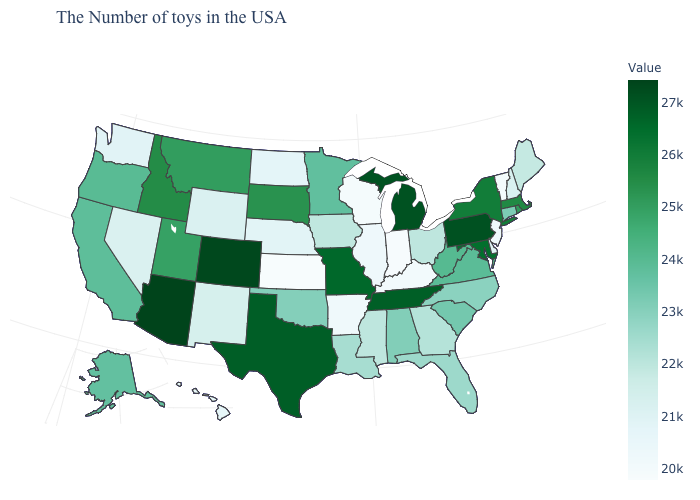Which states have the lowest value in the USA?
Quick response, please. Kansas. Among the states that border Vermont , which have the highest value?
Concise answer only. New York. Does Mississippi have the lowest value in the USA?
Keep it brief. No. Is the legend a continuous bar?
Answer briefly. Yes. Does Michigan have a lower value than North Carolina?
Quick response, please. No. 